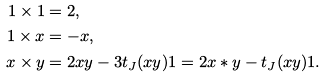Convert formula to latex. <formula><loc_0><loc_0><loc_500><loc_500>1 \times 1 & = 2 , \\ 1 \times x & = - x , \\ x \times y & = 2 x y - 3 t _ { J } ( x y ) 1 = 2 x * y - t _ { J } ( x y ) 1 .</formula> 